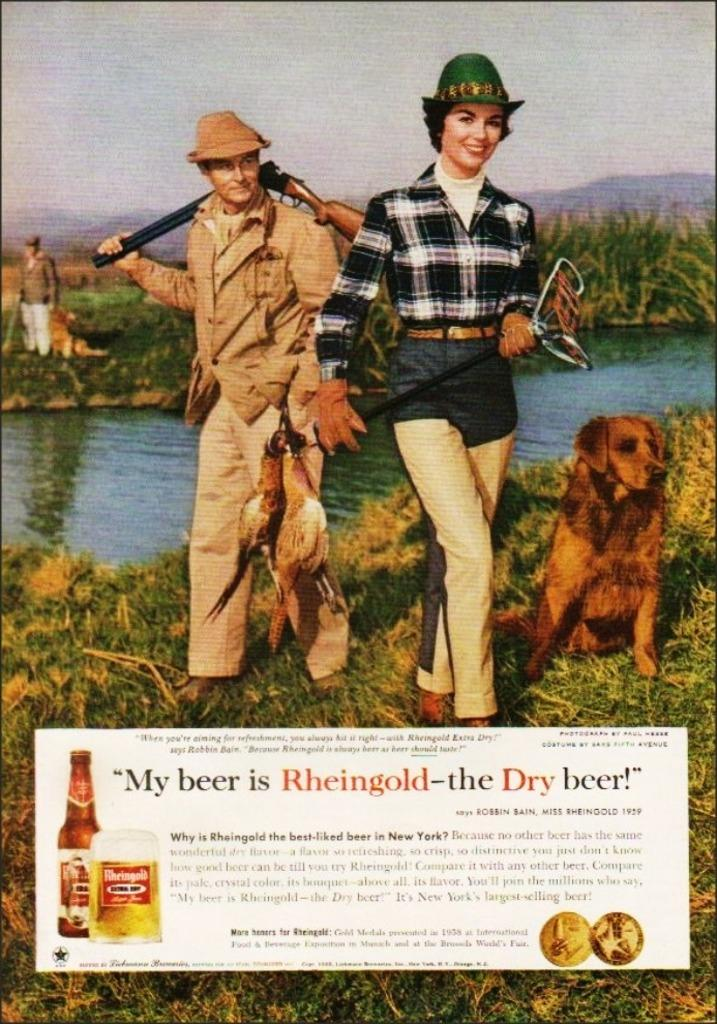What is the main subject of the image? The main subject of the image is a photo. What can be seen in the photo? The photo includes text, persons, an animal, birds, water, grass, and the sky. Can you describe the setting of the photo? The photo shows a scene with water, grass, and the sky visible. What type of light can be seen illuminating the mask in the image? There is no mask present in the image, so it is not possible to determine what type of light might be illuminating it. 